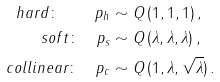<formula> <loc_0><loc_0><loc_500><loc_500>h a r d \colon \quad p _ { h } & \sim Q \, ( 1 , 1 , 1 ) \, , \\ s o f t \colon \quad p _ { s } & \sim Q \, ( \lambda , \lambda , \lambda ) \, , \\ c o l l i n e a r \colon \quad p _ { c } & \sim Q \, ( 1 , \lambda , \sqrt { \lambda } ) \, .</formula> 